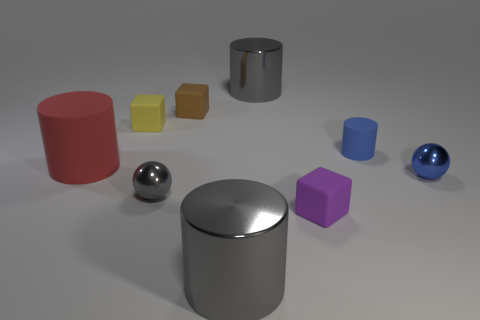What number of balls are yellow rubber things or blue objects?
Your response must be concise. 1. There is a brown object; is its size the same as the rubber cylinder that is in front of the blue rubber cylinder?
Offer a terse response. No. Are there more gray metallic cylinders behind the red thing than brown metal cubes?
Provide a short and direct response. Yes. There is a red thing that is the same material as the purple thing; what size is it?
Offer a terse response. Large. Is there a small shiny sphere of the same color as the tiny cylinder?
Keep it short and to the point. Yes. How many things are tiny yellow cubes or gray objects in front of the tiny blue rubber object?
Give a very brief answer. 3. Is the number of blue spheres greater than the number of cyan matte cylinders?
Keep it short and to the point. Yes. What is the size of the shiny ball that is the same color as the tiny cylinder?
Provide a short and direct response. Small. Are there any tiny purple objects made of the same material as the big red thing?
Give a very brief answer. Yes. The object that is to the right of the red thing and left of the gray sphere has what shape?
Your response must be concise. Cube. 